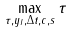Convert formula to latex. <formula><loc_0><loc_0><loc_500><loc_500>\max _ { \tau , y _ { I } , \Delta t , c , s } \tau</formula> 